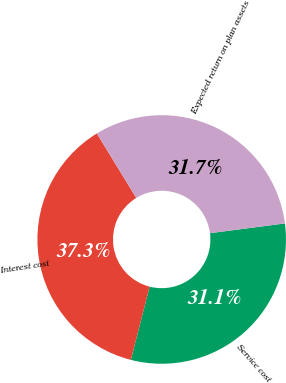<chart> <loc_0><loc_0><loc_500><loc_500><pie_chart><fcel>Service cost<fcel>Interest cost<fcel>Expected return on plan assets<nl><fcel>31.06%<fcel>37.27%<fcel>31.68%<nl></chart> 